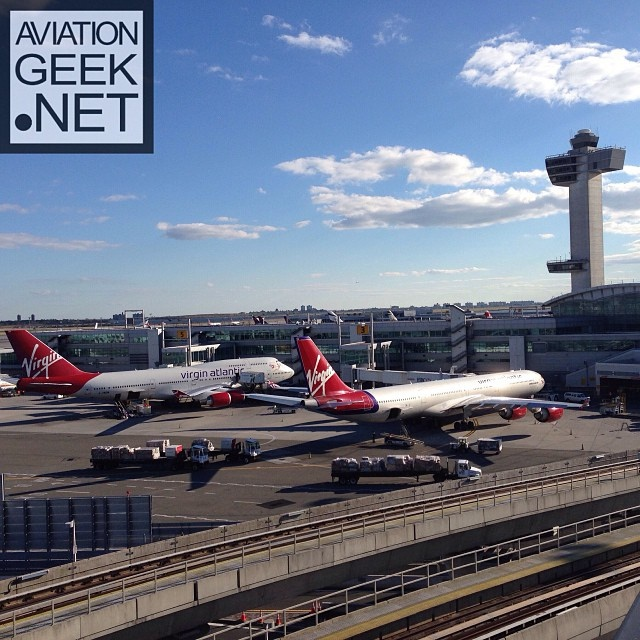Describe the objects in this image and their specific colors. I can see airplane in black, white, darkgray, and gray tones, airplane in black, darkgray, gray, and maroon tones, truck in black, gray, and darkgray tones, truck in black, gray, darkgray, and lightgray tones, and truck in black, gray, and darkgray tones in this image. 